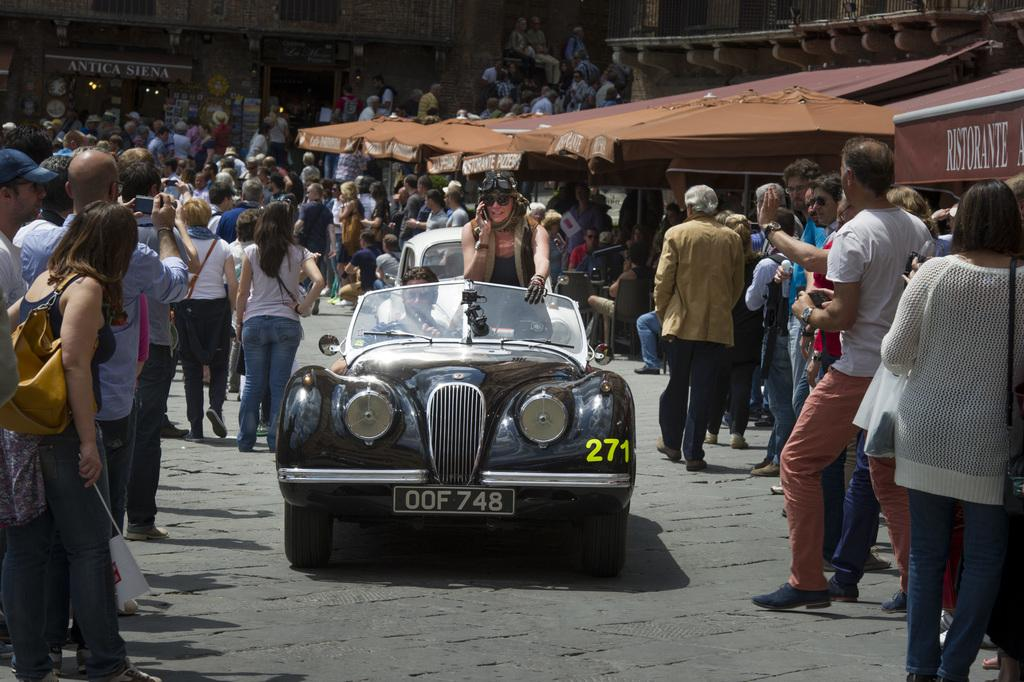How many people are in the image? There is a group of people in the image. What are the people in the image doing? The people are standing. Can you describe the activity involving a car in the image? There are two persons riding on a car in the center of the image. What can be seen in the background of the image? There is a tent visible in the background of the image. How many frogs are sitting on the faucet in the image? There are no frogs or faucets present in the image. 